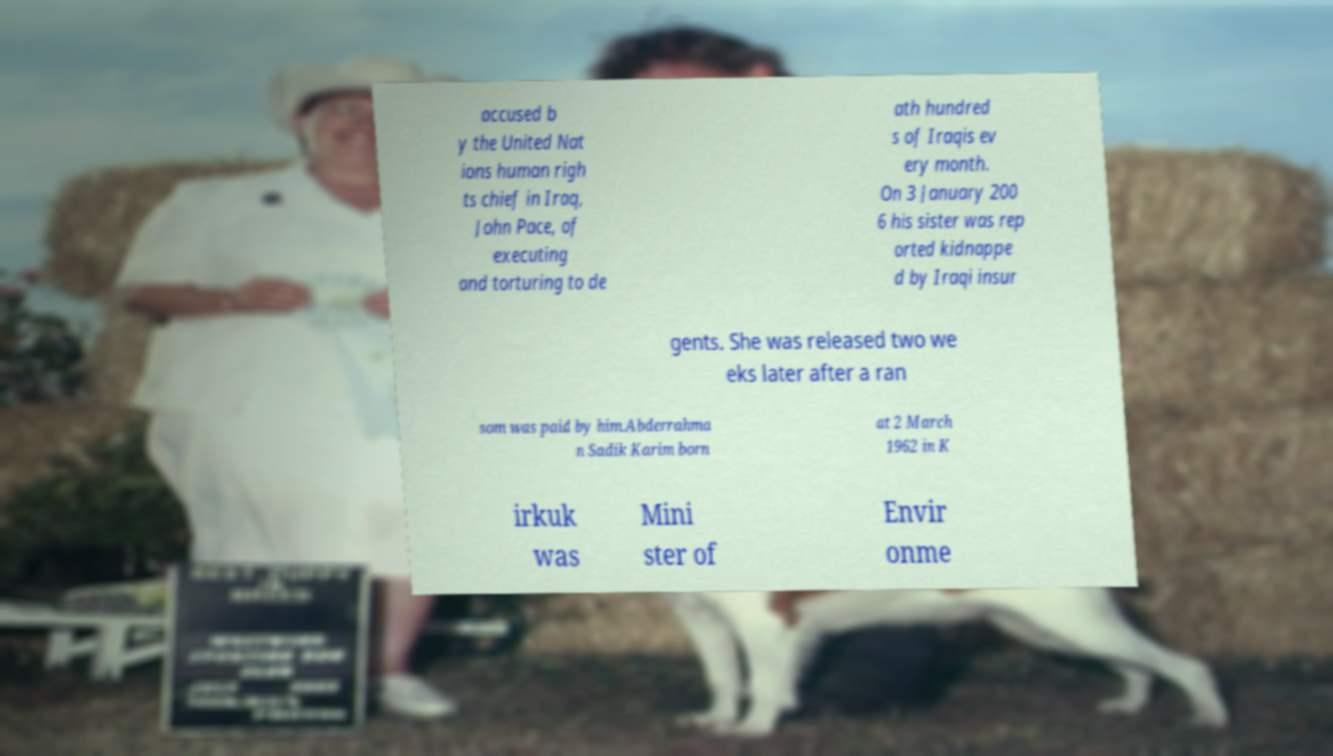There's text embedded in this image that I need extracted. Can you transcribe it verbatim? accused b y the United Nat ions human righ ts chief in Iraq, John Pace, of executing and torturing to de ath hundred s of Iraqis ev ery month. On 3 January 200 6 his sister was rep orted kidnappe d by Iraqi insur gents. She was released two we eks later after a ran som was paid by him.Abderrahma n Sadik Karim born at 2 March 1962 in K irkuk was Mini ster of Envir onme 